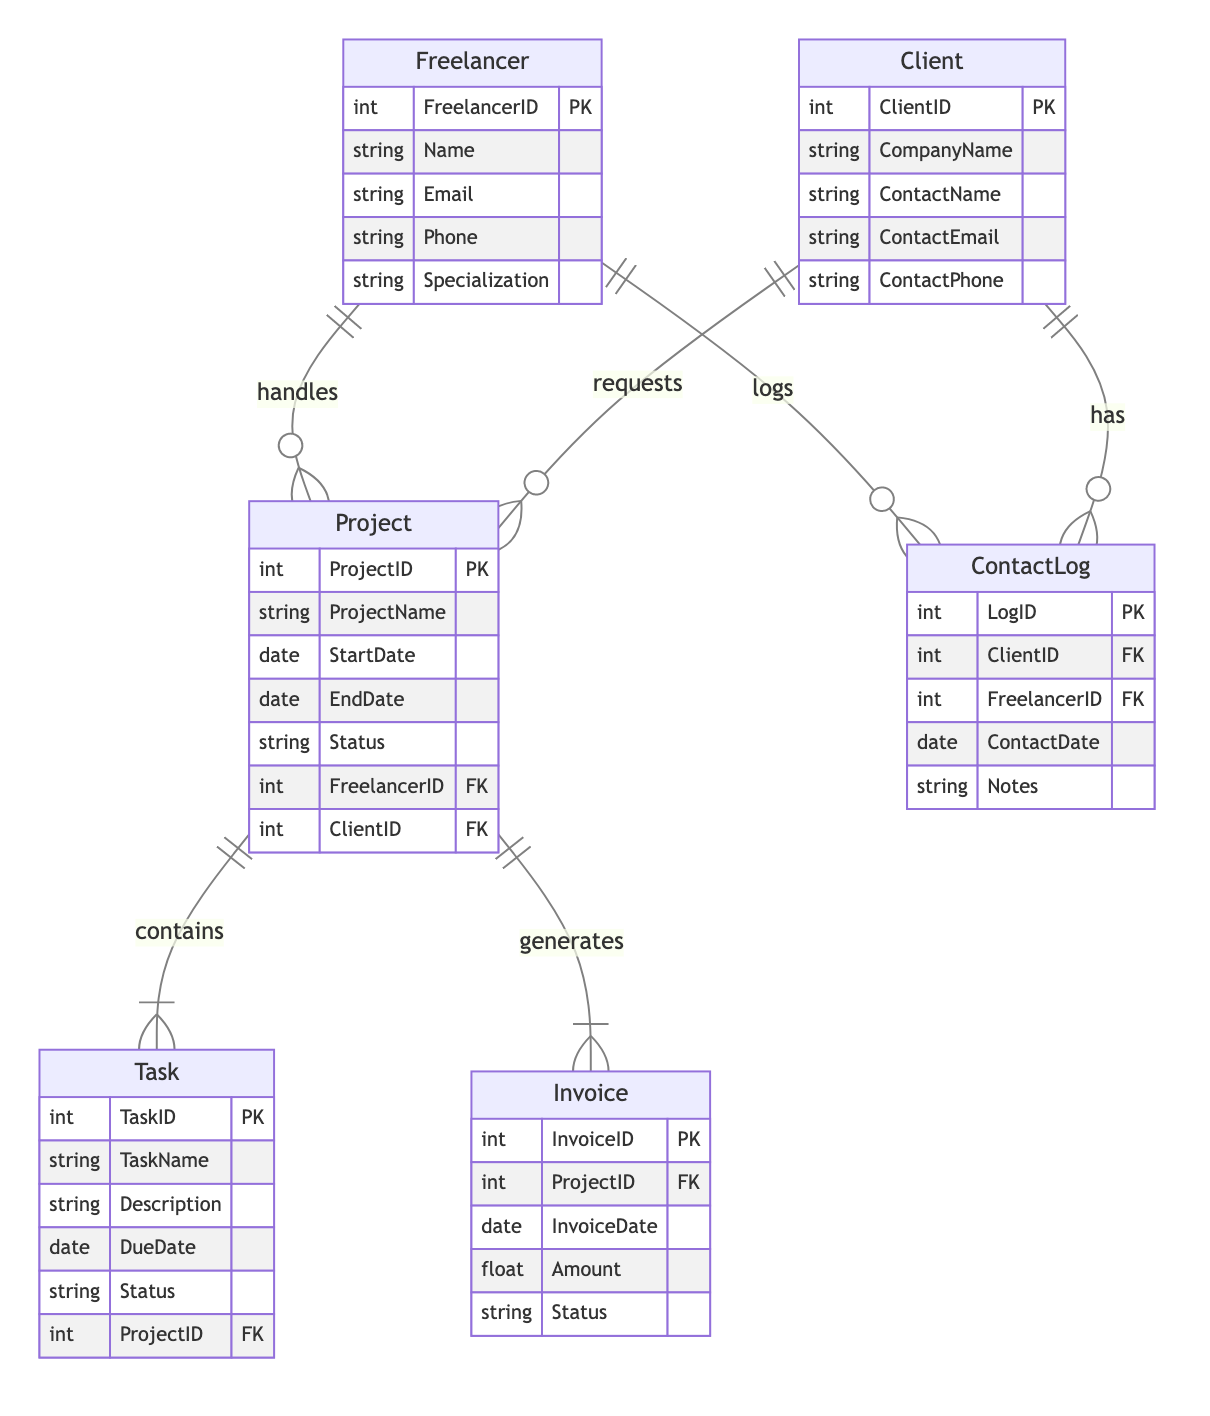What is the primary key of the Freelancer entity? The primary key is an attribute that uniquely identifies each record within an entity. In the Freelancer entity, the primary key is specified as FreelancerID.
Answer: FreelancerID How many attributes does the Client entity have? By counting the listed attributes in the Client entity, we find five: ClientID, CompanyName, ContactName, ContactEmail, and ContactPhone. Thus, there are five attributes.
Answer: Five What relationship exists between the Client and Project entities? The diagram indicates that the Client entity requests projects, establishing a one-to-many relationship, where one client can request multiple projects.
Answer: requests How many entities are represented in the diagram? The diagram includes a total of five distinct entities: Freelancer, Client, Project, Invoice, Task, and ContactLog, which adds up to six entities in total.
Answer: Six What is the foreign key in the Invoice entity? The Invoice entity includes one foreign key, which is used to link it to another entity. The foreign key in this case is ProjectID, referencing the Project entity.
Answer: ProjectID Which entity holds the relationship logged by ContactLog? The ContactLog entity logs interactions between freelancers and clients, indicating that it has relationships with both the Freelancer and Client entities, as seen in the foreign key references.
Answer: Freelancer and Client What does the Project entity generate? According to the diagram, the Project entity is responsible for generating invoices, indicating its central role in managing monetary exchanges related to the work completed.
Answer: generates How many tasks are associated with a project? The Task entity is linked to the Project entity through a one-to-many relationship, meaning that a single project can have multiple associated tasks.
Answer: multiple 